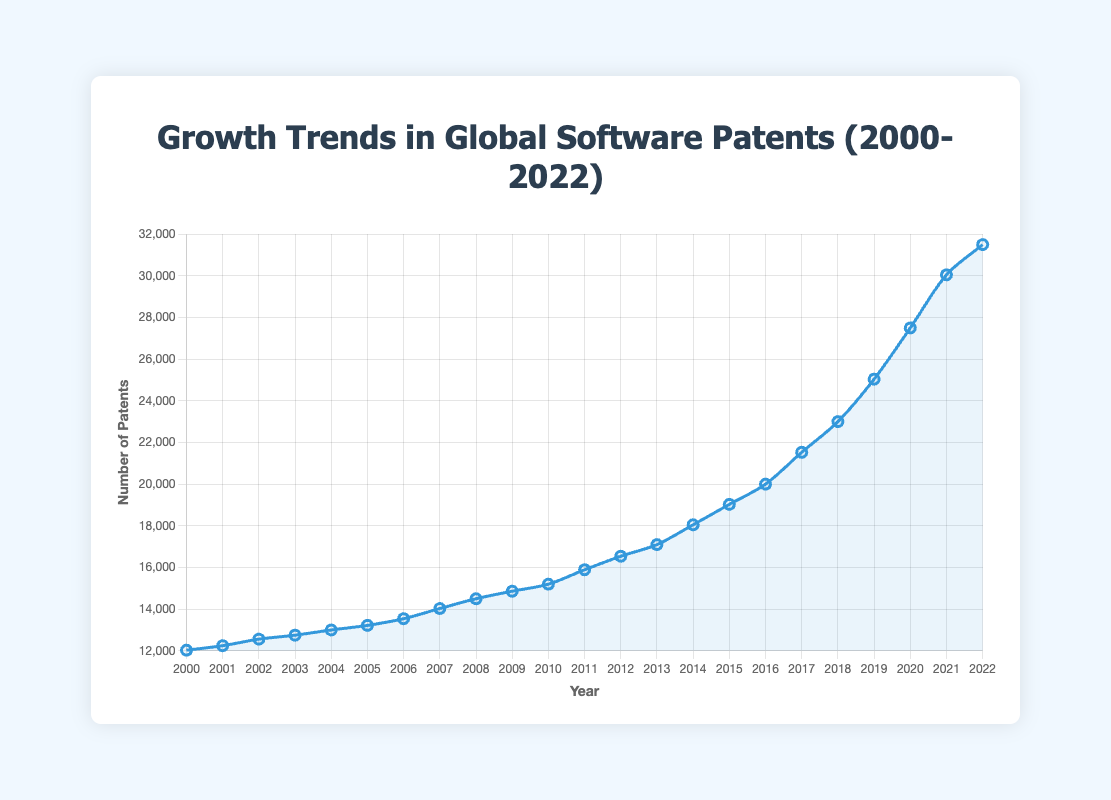What was the overall trend in the number of software patents from 2000 to 2022? The line plot shows a general upward trend in the number of software patents issued from 2000 to 2022. Starting at 12030 in 2000, the numbers steadily increase year by year, reaching 31500 in 2022.
Answer: Upward trend Which year had the highest number of software patents issued? By looking at the highest point on the line plot, the year with the peak number of software patents is identified. The peak is in 2022 with 31500 patents.
Answer: 2022 How many patents were issued in 2010 compared to 2000? The number of patents issued in 2010 is 15200, whereas in 2000, it was 12030. Subtracting the values, 15200 - 12030 = 3170.
Answer: 3170 How did the number of software patents change from 2015 to 2020? The number of patents in 2015 was 19030 and in 2020 it was 27500. The difference is 27500 - 19030 = 8470.
Answer: 8470 What was the average number of software patents issued between 2000 and 2005? Sum the number of patents from 2000 to 2005: 12030 + 12245 + 12560 + 12750 + 13000 + 13220 = 75805. Then divide by 6 years: 75805 / 6 ≈ 12634.
Answer: 12634 Which decade saw the greatest increase in software patents? Compare the number of patents from 2000 to 2010 with those from 2010 to 2020. Calculating the increase:
For 2000 to 2010: 15200 - 12030 = 3170
For 2010 to 2020: 27500 - 15200 = 12300
The greatest increase is from 2010 to 2020.
Answer: 2010-2020 Identify any years where there was a noticeable spike or dip in the number of patents issued. Observing the line plot, a noticeable spike is observed around 2017-2019. For a dip, there is no significant drop, but the increase is slower between 2008 and 2009.
Answer: 2017-2019 (spike), 2008-2009 (slower increase) What is the median number of software patents issued from 2000 to 2022? The values from 2000 to 2022 (23 years) are sorted, the median is the middle value in an odd set. The middle value is the 12th value when sorted, which is 15890 from 2011.
Answer: 15890 